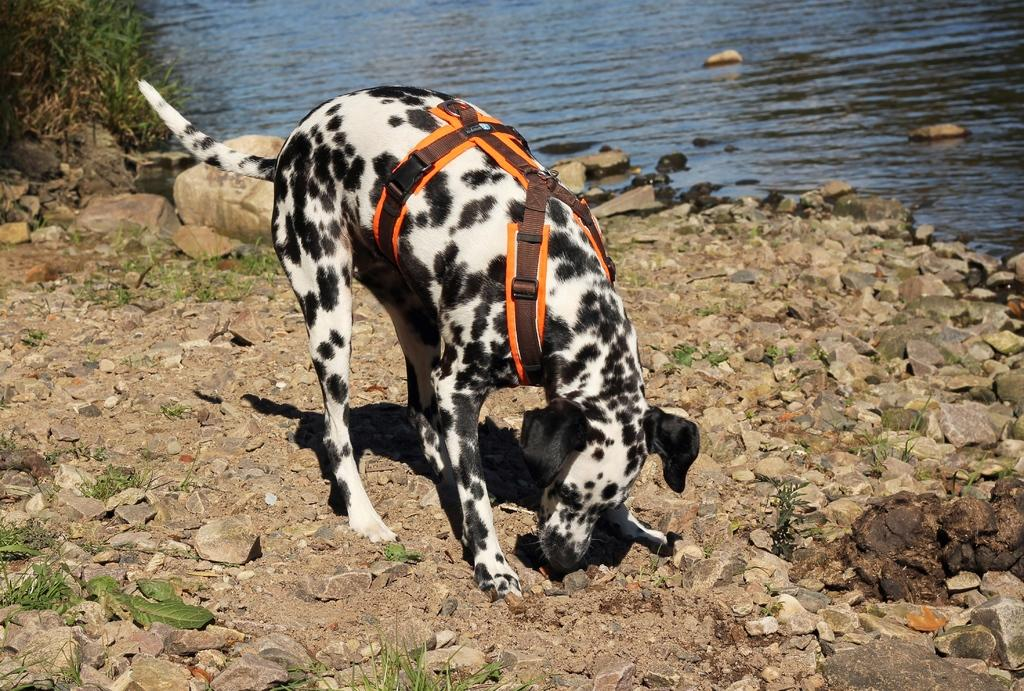What is the main subject in the foreground of the image? There is a dog in the foreground of the image. What is the dog wearing in the image? The dog is wearing a belt in the image. What type of natural elements can be seen in the image? There are many rocks in the image. What can be seen in the background of the image? There is water visible in the background of the image. How many children are running around the dog in the image? There are no children present in the image, and the dog is not running. 